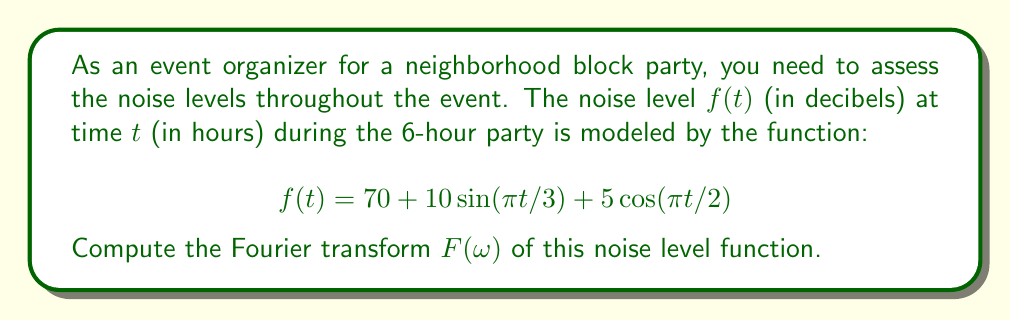Help me with this question. To compute the Fourier transform, we'll follow these steps:

1) The Fourier transform is defined as:
   $$F(\omega) = \int_{-\infty}^{\infty} f(t)e^{-i\omega t}dt$$

2) Our function $f(t)$ has three components:
   a) Constant term: 70
   b) Sine term: $10\sin(\pi t/3)$
   c) Cosine term: $5\cos(\pi t/2)$

3) For the constant term:
   $$\mathcal{F}\{70\} = 70 \cdot 2\pi\delta(\omega)$$

4) For the sine term, we use the Fourier transform property:
   $$\mathcal{F}\{sin(at)\} = \frac{i\pi}{2}[\delta(\omega-a) - \delta(\omega+a)]$$
   With $a = \pi/3$, we get:
   $$\mathcal{F}\{10\sin(\pi t/3)\} = 5\pi i[\delta(\omega-\pi/3) - \delta(\omega+\pi/3)]$$

5) For the cosine term, we use:
   $$\mathcal{F}\{cos(at)\} = \pi[\delta(\omega-a) + \delta(\omega+a)]$$
   With $a = \pi/2$, we get:
   $$\mathcal{F}\{5\cos(\pi t/2)\} = 5\pi[\delta(\omega-\pi/2) + \delta(\omega+\pi/2)]$$

6) Combining all terms:
   $$F(\omega) = 70 \cdot 2\pi\delta(\omega) + 5\pi i[\delta(\omega-\pi/3) - \delta(\omega+\pi/3)] + 5\pi[\delta(\omega-\pi/2) + \delta(\omega+\pi/2)]$$
Answer: $$F(\omega) = 140\pi\delta(\omega) + 5\pi i[\delta(\omega-\pi/3) - \delta(\omega+\pi/3)] + 5\pi[\delta(\omega-\pi/2) + \delta(\omega+\pi/2)]$$ 